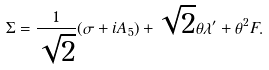<formula> <loc_0><loc_0><loc_500><loc_500>\Sigma = \frac { 1 } { \sqrt { 2 } } ( \sigma + i A _ { 5 } ) + \sqrt { 2 } \theta \lambda ^ { \prime } + \theta ^ { 2 } F .</formula> 